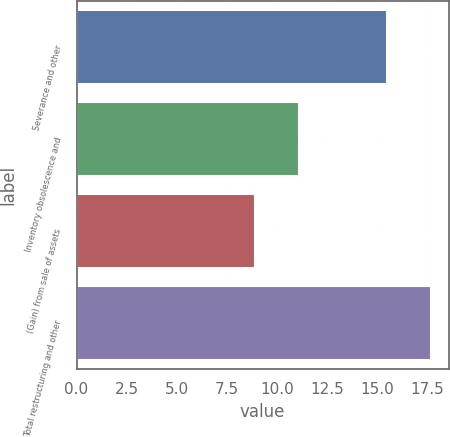Convert chart to OTSL. <chart><loc_0><loc_0><loc_500><loc_500><bar_chart><fcel>Severance and other<fcel>Inventory obsolescence and<fcel>(Gain) from sale of assets<fcel>Total restructuring and other<nl><fcel>15.5<fcel>11.1<fcel>8.9<fcel>17.7<nl></chart> 